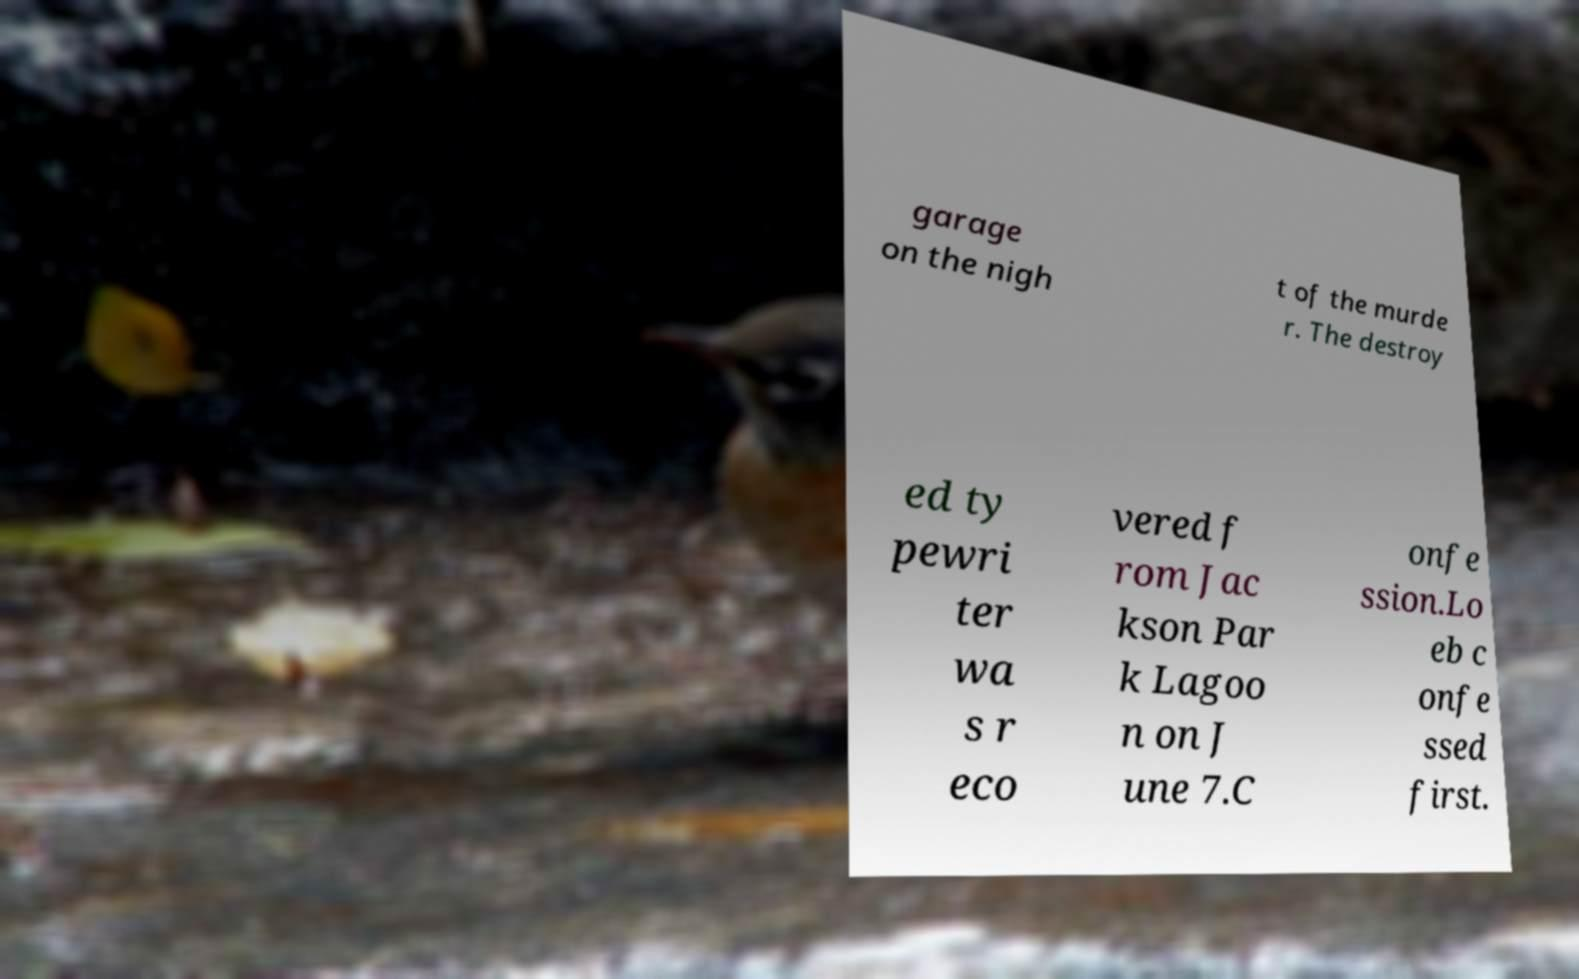What messages or text are displayed in this image? I need them in a readable, typed format. garage on the nigh t of the murde r. The destroy ed ty pewri ter wa s r eco vered f rom Jac kson Par k Lagoo n on J une 7.C onfe ssion.Lo eb c onfe ssed first. 